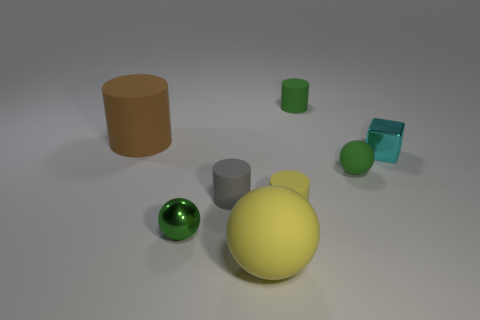How do the objects in the image relate to each other? The objects don't have a clear functional relationship but are composed together in a way that provides a variety of shapes and sizes for visual contrast. The arrangement could be used to study geometric forms or create an aesthetically pleasing still life composition. 